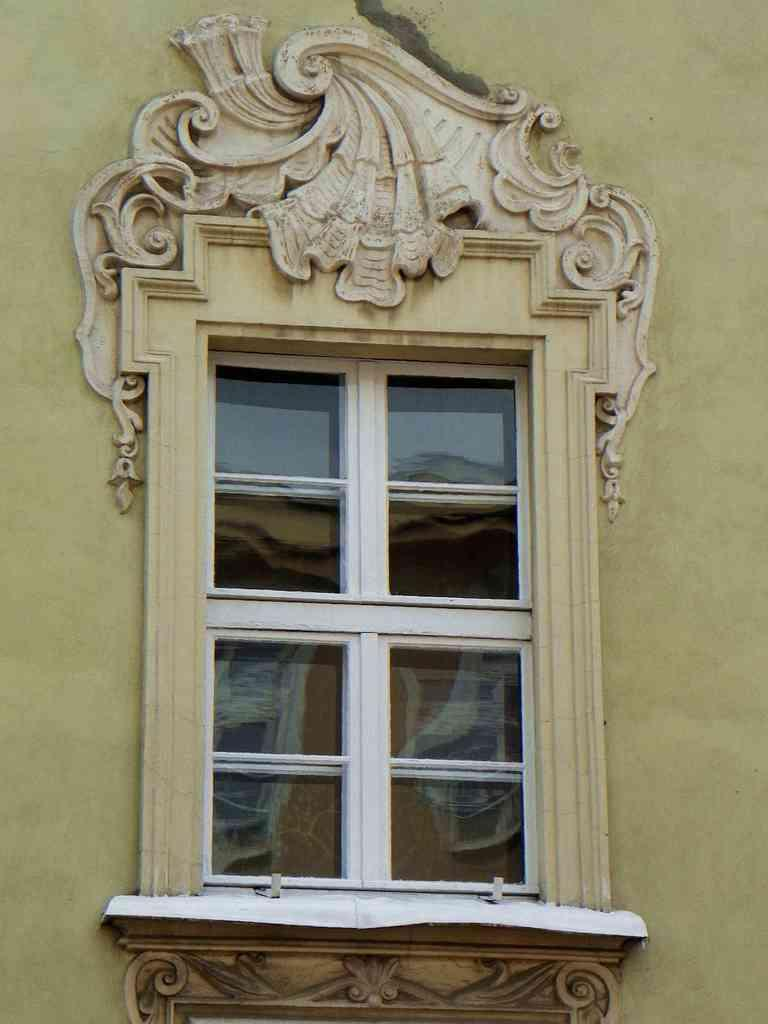What can be seen in the image that allows light to enter a room? There is a window in the image. What is the window attached to in the image? The window is connected to a wall. What color is the wall that the window is attached to? The wall is in cream color. What type of journey does the heart take in the image? There is no heart or journey present in the image. 